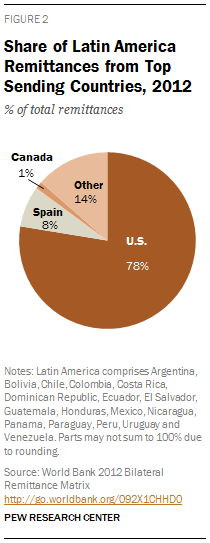List a handful of essential elements in this visual. Of the segments, how many have a value below 20%? According to the information provided, 8% of total remittances in Spain were received during the specified time period. 